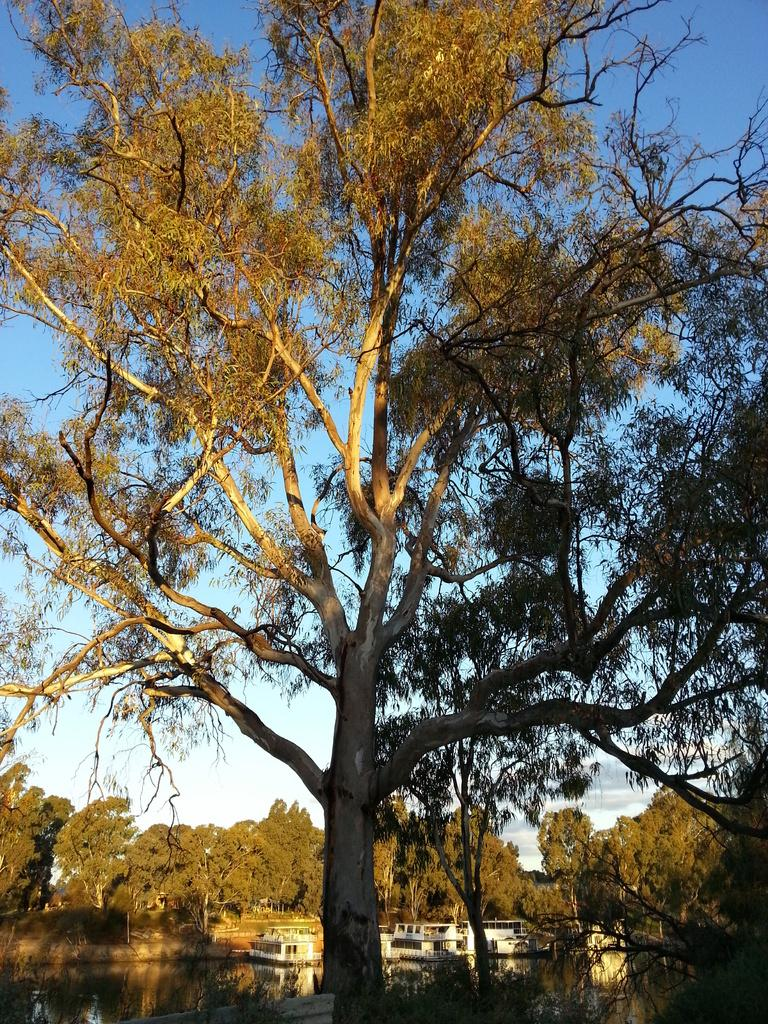What is depicted in the image? There are boats in the image. Where are the boats located? The boats are on a river. What can be seen in the background of the image? There are trees around the river in the image. How many dimes can be seen floating in the river in the image? There are no dimes present in the image; it features boats on a river with trees in the background. 